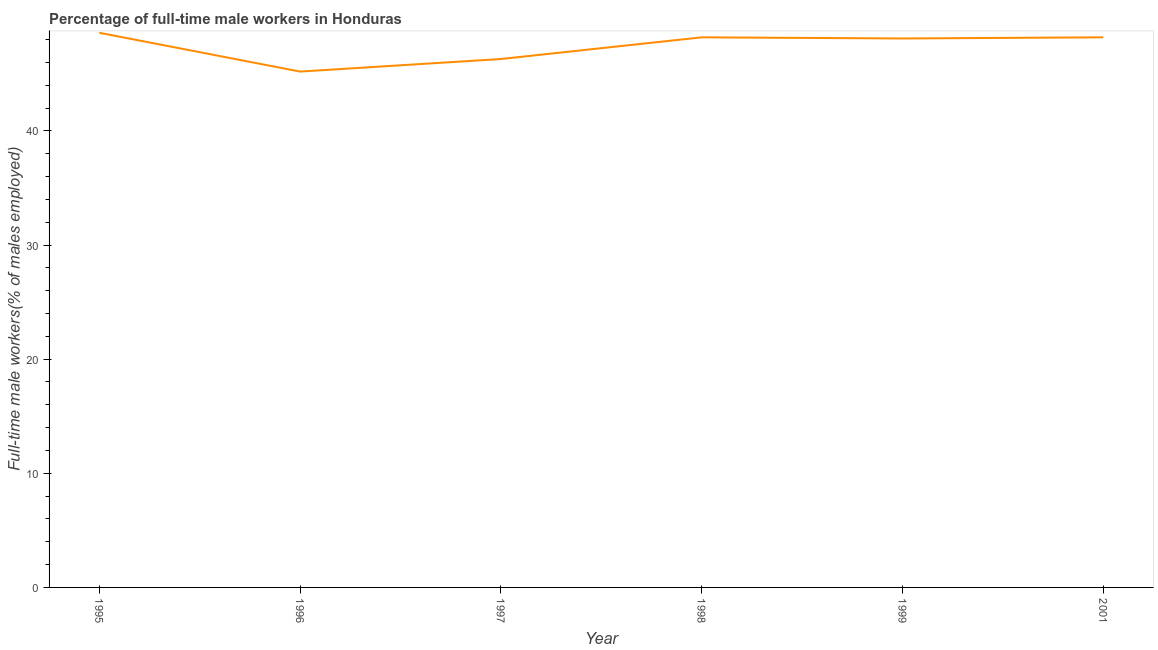What is the percentage of full-time male workers in 1995?
Your response must be concise. 48.6. Across all years, what is the maximum percentage of full-time male workers?
Ensure brevity in your answer.  48.6. Across all years, what is the minimum percentage of full-time male workers?
Your answer should be very brief. 45.2. In which year was the percentage of full-time male workers maximum?
Provide a succinct answer. 1995. In which year was the percentage of full-time male workers minimum?
Your answer should be compact. 1996. What is the sum of the percentage of full-time male workers?
Make the answer very short. 284.6. What is the difference between the percentage of full-time male workers in 1997 and 2001?
Offer a very short reply. -1.9. What is the average percentage of full-time male workers per year?
Your answer should be compact. 47.43. What is the median percentage of full-time male workers?
Provide a succinct answer. 48.15. In how many years, is the percentage of full-time male workers greater than 44 %?
Ensure brevity in your answer.  6. What is the ratio of the percentage of full-time male workers in 1998 to that in 2001?
Your response must be concise. 1. Is the percentage of full-time male workers in 1996 less than that in 1999?
Your answer should be very brief. Yes. Is the difference between the percentage of full-time male workers in 1999 and 2001 greater than the difference between any two years?
Offer a terse response. No. What is the difference between the highest and the second highest percentage of full-time male workers?
Provide a short and direct response. 0.4. Is the sum of the percentage of full-time male workers in 1997 and 2001 greater than the maximum percentage of full-time male workers across all years?
Make the answer very short. Yes. What is the difference between the highest and the lowest percentage of full-time male workers?
Provide a short and direct response. 3.4. In how many years, is the percentage of full-time male workers greater than the average percentage of full-time male workers taken over all years?
Give a very brief answer. 4. Does the percentage of full-time male workers monotonically increase over the years?
Ensure brevity in your answer.  No. How many lines are there?
Your response must be concise. 1. Are the values on the major ticks of Y-axis written in scientific E-notation?
Your answer should be compact. No. Does the graph contain any zero values?
Make the answer very short. No. Does the graph contain grids?
Your response must be concise. No. What is the title of the graph?
Your response must be concise. Percentage of full-time male workers in Honduras. What is the label or title of the X-axis?
Offer a very short reply. Year. What is the label or title of the Y-axis?
Offer a terse response. Full-time male workers(% of males employed). What is the Full-time male workers(% of males employed) of 1995?
Offer a very short reply. 48.6. What is the Full-time male workers(% of males employed) in 1996?
Provide a short and direct response. 45.2. What is the Full-time male workers(% of males employed) of 1997?
Offer a terse response. 46.3. What is the Full-time male workers(% of males employed) of 1998?
Offer a very short reply. 48.2. What is the Full-time male workers(% of males employed) in 1999?
Keep it short and to the point. 48.1. What is the Full-time male workers(% of males employed) in 2001?
Make the answer very short. 48.2. What is the difference between the Full-time male workers(% of males employed) in 1995 and 1996?
Ensure brevity in your answer.  3.4. What is the difference between the Full-time male workers(% of males employed) in 1995 and 1997?
Provide a short and direct response. 2.3. What is the difference between the Full-time male workers(% of males employed) in 1996 and 1999?
Make the answer very short. -2.9. What is the difference between the Full-time male workers(% of males employed) in 1996 and 2001?
Your response must be concise. -3. What is the ratio of the Full-time male workers(% of males employed) in 1995 to that in 1996?
Offer a terse response. 1.07. What is the ratio of the Full-time male workers(% of males employed) in 1995 to that in 1997?
Provide a succinct answer. 1.05. What is the ratio of the Full-time male workers(% of males employed) in 1995 to that in 1998?
Offer a very short reply. 1.01. What is the ratio of the Full-time male workers(% of males employed) in 1995 to that in 1999?
Offer a terse response. 1.01. What is the ratio of the Full-time male workers(% of males employed) in 1996 to that in 1998?
Your answer should be compact. 0.94. What is the ratio of the Full-time male workers(% of males employed) in 1996 to that in 2001?
Give a very brief answer. 0.94. What is the ratio of the Full-time male workers(% of males employed) in 1997 to that in 1998?
Provide a succinct answer. 0.96. 